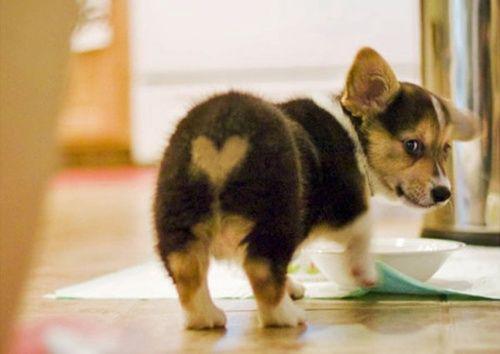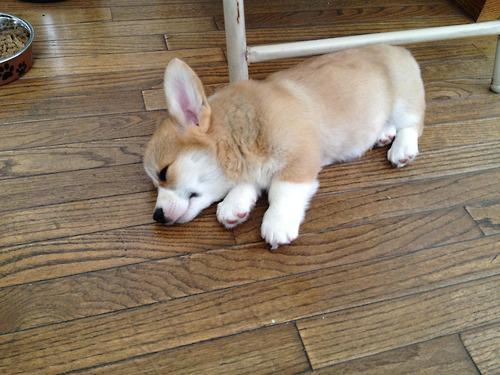The first image is the image on the left, the second image is the image on the right. Examine the images to the left and right. Is the description "One if the images has three dogs looking at the camera." accurate? Answer yes or no. No. The first image is the image on the left, the second image is the image on the right. For the images displayed, is the sentence "The left image shows one corgi with its rear to the camera, standing on all fours and looking over one shoulder." factually correct? Answer yes or no. Yes. 